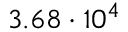<formula> <loc_0><loc_0><loc_500><loc_500>3 . 6 8 \cdot 1 0 ^ { 4 }</formula> 